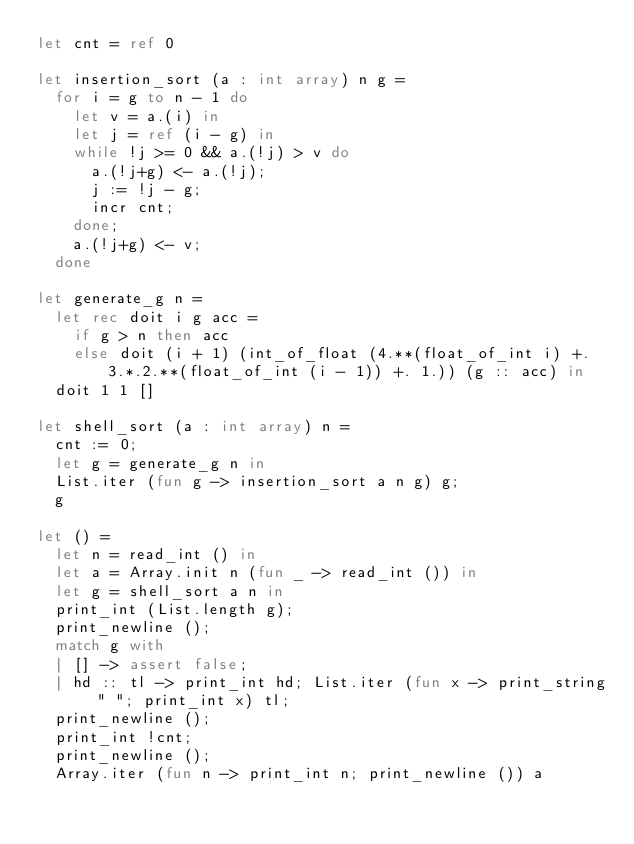Convert code to text. <code><loc_0><loc_0><loc_500><loc_500><_OCaml_>let cnt = ref 0

let insertion_sort (a : int array) n g =
  for i = g to n - 1 do
    let v = a.(i) in
    let j = ref (i - g) in
    while !j >= 0 && a.(!j) > v do
      a.(!j+g) <- a.(!j);
      j := !j - g;
      incr cnt;
    done;
    a.(!j+g) <- v;
  done

let generate_g n =
  let rec doit i g acc =
    if g > n then acc
    else doit (i + 1) (int_of_float (4.**(float_of_int i) +. 3.*.2.**(float_of_int (i - 1)) +. 1.)) (g :: acc) in
  doit 1 1 []

let shell_sort (a : int array) n =
  cnt := 0;
  let g = generate_g n in
  List.iter (fun g -> insertion_sort a n g) g;
  g

let () =
  let n = read_int () in
  let a = Array.init n (fun _ -> read_int ()) in
  let g = shell_sort a n in
  print_int (List.length g);
  print_newline ();
  match g with
  | [] -> assert false;
  | hd :: tl -> print_int hd; List.iter (fun x -> print_string " "; print_int x) tl;
  print_newline ();
  print_int !cnt;
  print_newline ();
  Array.iter (fun n -> print_int n; print_newline ()) a</code> 